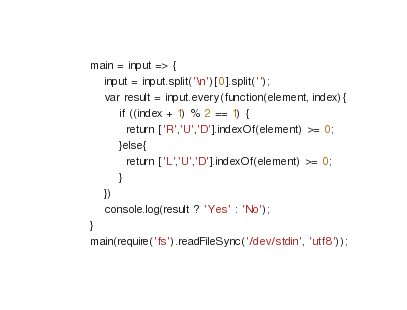<code> <loc_0><loc_0><loc_500><loc_500><_JavaScript_>main = input => {
    input = input.split('\n')[0].split('');
    var result = input.every(function(element, index){
        if ((index + 1) % 2 == 1) {
          return ['R','U','D'].indexOf(element) >= 0;
        }else{
          return ['L','U','D'].indexOf(element) >= 0;
        }
    })
    console.log(result ? 'Yes' : 'No');
}
main(require('fs').readFileSync('/dev/stdin', 'utf8'));</code> 